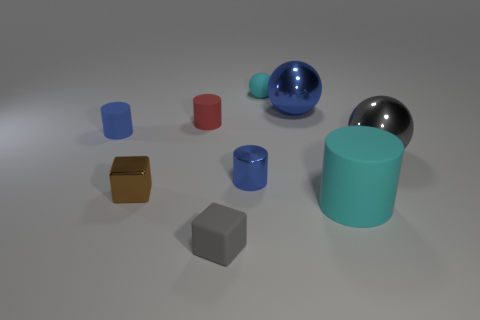Add 1 large blue metallic objects. How many objects exist? 10 Subtract all gray balls. How many balls are left? 2 Subtract all brown cylinders. How many blue cubes are left? 0 Subtract all small blue matte cylinders. Subtract all big yellow spheres. How many objects are left? 8 Add 9 tiny cyan matte things. How many tiny cyan matte things are left? 10 Add 9 tiny cyan metallic cylinders. How many tiny cyan metallic cylinders exist? 9 Subtract all red cylinders. How many cylinders are left? 3 Subtract 0 brown balls. How many objects are left? 9 Subtract all blocks. How many objects are left? 7 Subtract 1 cylinders. How many cylinders are left? 3 